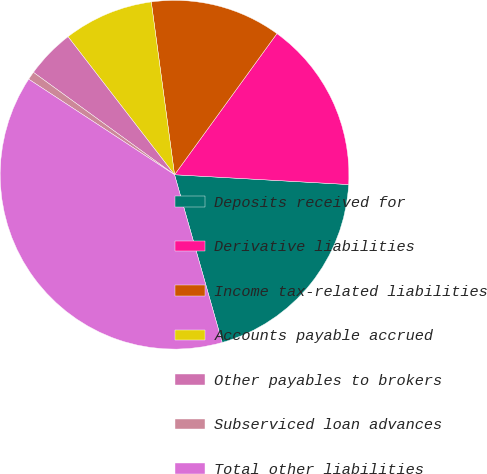Convert chart to OTSL. <chart><loc_0><loc_0><loc_500><loc_500><pie_chart><fcel>Deposits received for<fcel>Derivative liabilities<fcel>Income tax-related liabilities<fcel>Accounts payable accrued<fcel>Other payables to brokers<fcel>Subserviced loan advances<fcel>Total other liabilities<nl><fcel>19.7%<fcel>15.91%<fcel>12.12%<fcel>8.33%<fcel>4.55%<fcel>0.76%<fcel>38.64%<nl></chart> 